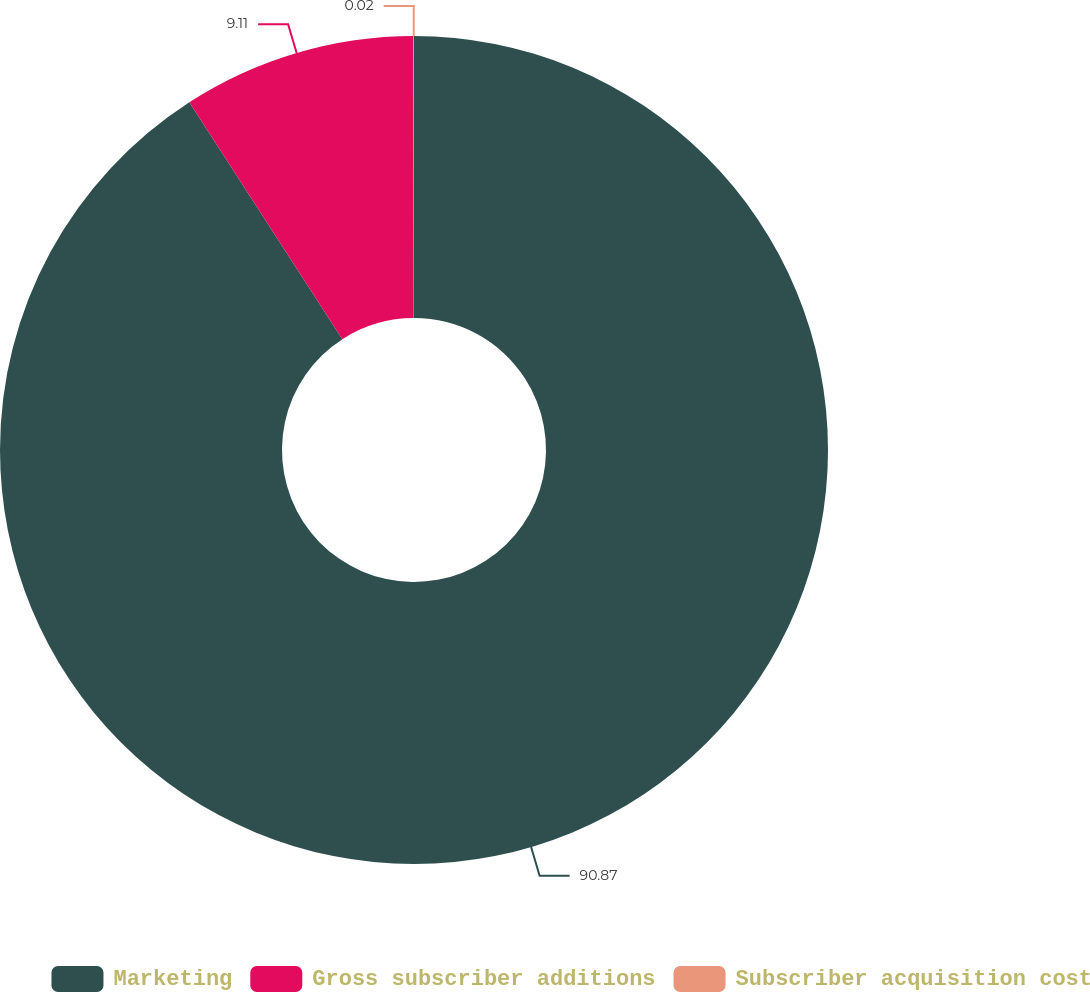<chart> <loc_0><loc_0><loc_500><loc_500><pie_chart><fcel>Marketing<fcel>Gross subscriber additions<fcel>Subscriber acquisition cost<nl><fcel>90.87%<fcel>9.11%<fcel>0.02%<nl></chart> 